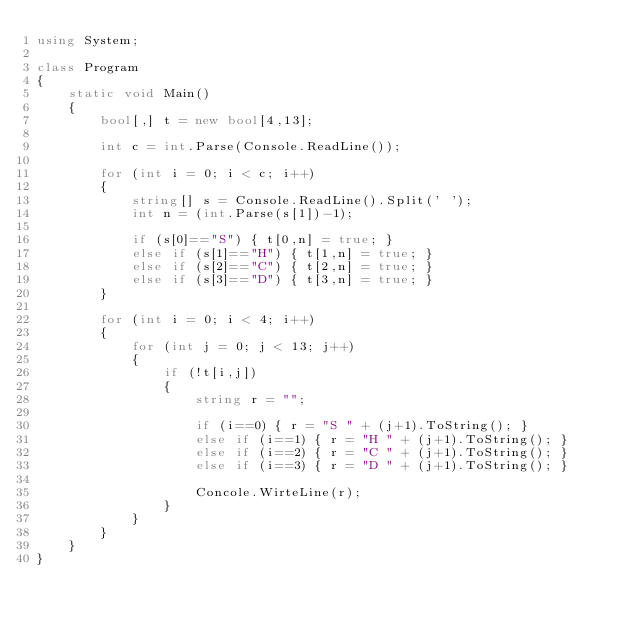<code> <loc_0><loc_0><loc_500><loc_500><_C#_>using System;
 
class Program
{
    static void Main()
    {
        bool[,] t = new bool[4,13];
        
        int c = int.Parse(Console.ReadLine());
        
        for (int i = 0; i < c; i++)
        {
            string[] s = Console.ReadLine().Split(' ');
            int n = (int.Parse(s[1])-1);
            
            if (s[0]=="S") { t[0,n] = true; }
            else if (s[1]=="H") { t[1,n] = true; }
            else if (s[2]=="C") { t[2,n] = true; }
            else if (s[3]=="D") { t[3,n] = true; }
        }
        
        for (int i = 0; i < 4; i++)
        {
            for (int j = 0; j < 13; j++)
            {
                if (!t[i,j])
                {
                    string r = "";
                    
                    if (i==0) { r = "S " + (j+1).ToString(); }
                    else if (i==1) { r = "H " + (j+1).ToString(); } 
                    else if (i==2) { r = "C " + (j+1).ToString(); } 
                    else if (i==3) { r = "D " + (j+1).ToString(); } 
                    
                    Concole.WirteLine(r);
                }
            }
        }
    }
}
</code> 